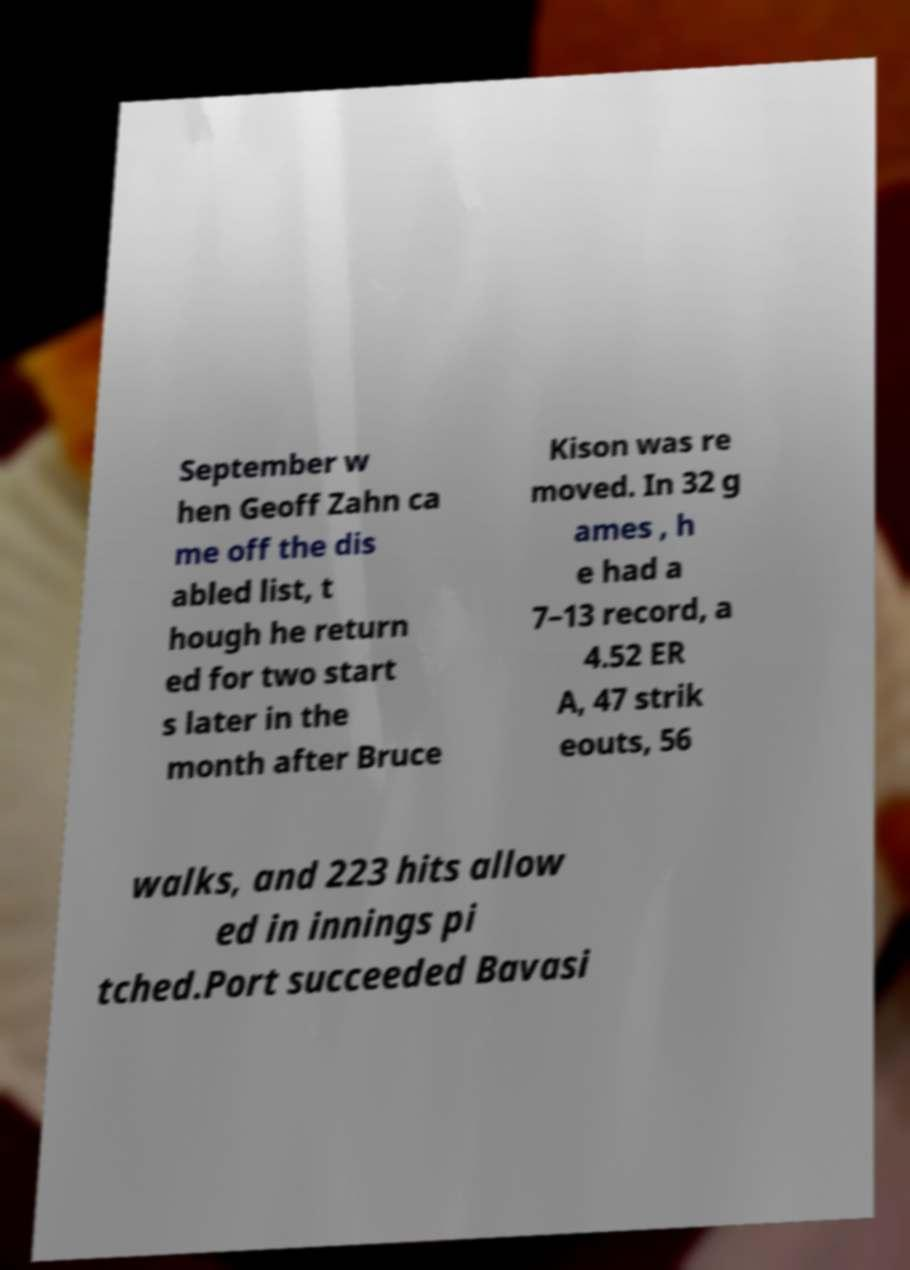What messages or text are displayed in this image? I need them in a readable, typed format. September w hen Geoff Zahn ca me off the dis abled list, t hough he return ed for two start s later in the month after Bruce Kison was re moved. In 32 g ames , h e had a 7–13 record, a 4.52 ER A, 47 strik eouts, 56 walks, and 223 hits allow ed in innings pi tched.Port succeeded Bavasi 